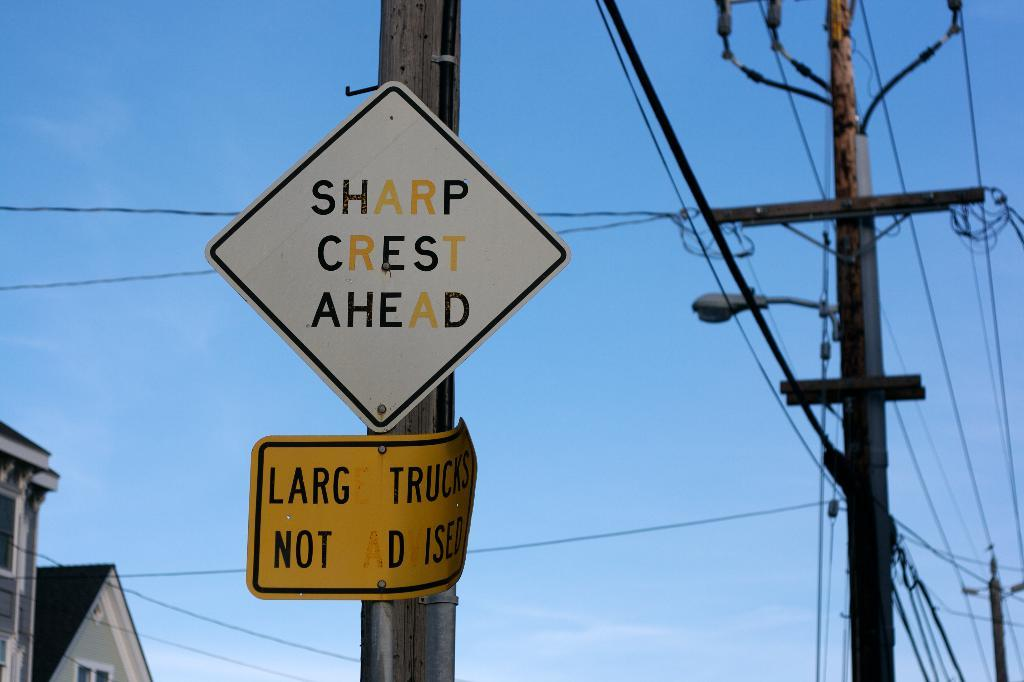Provide a one-sentence caption for the provided image. Sharp crest ahead sign is on a pole. 